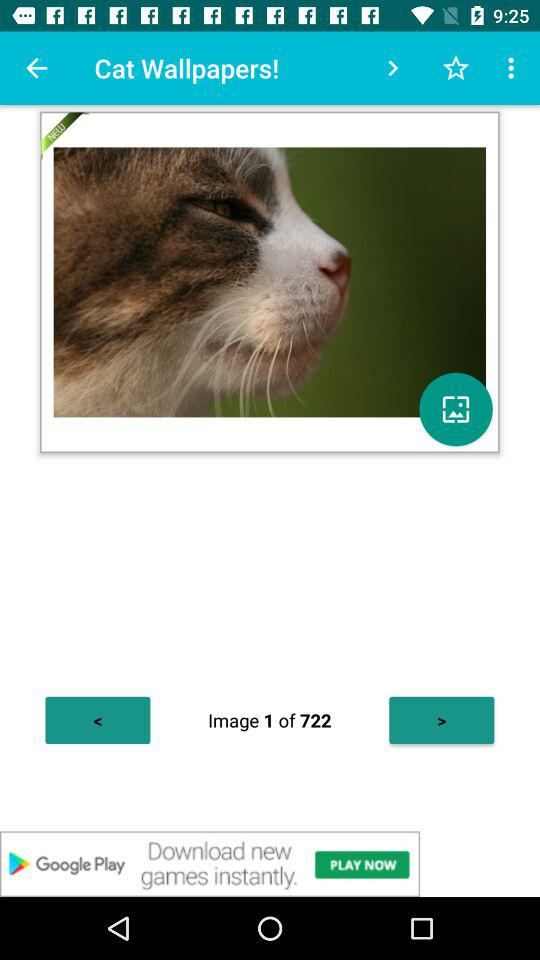How many more arrows are there pointing left than right?
Answer the question using a single word or phrase. 1 